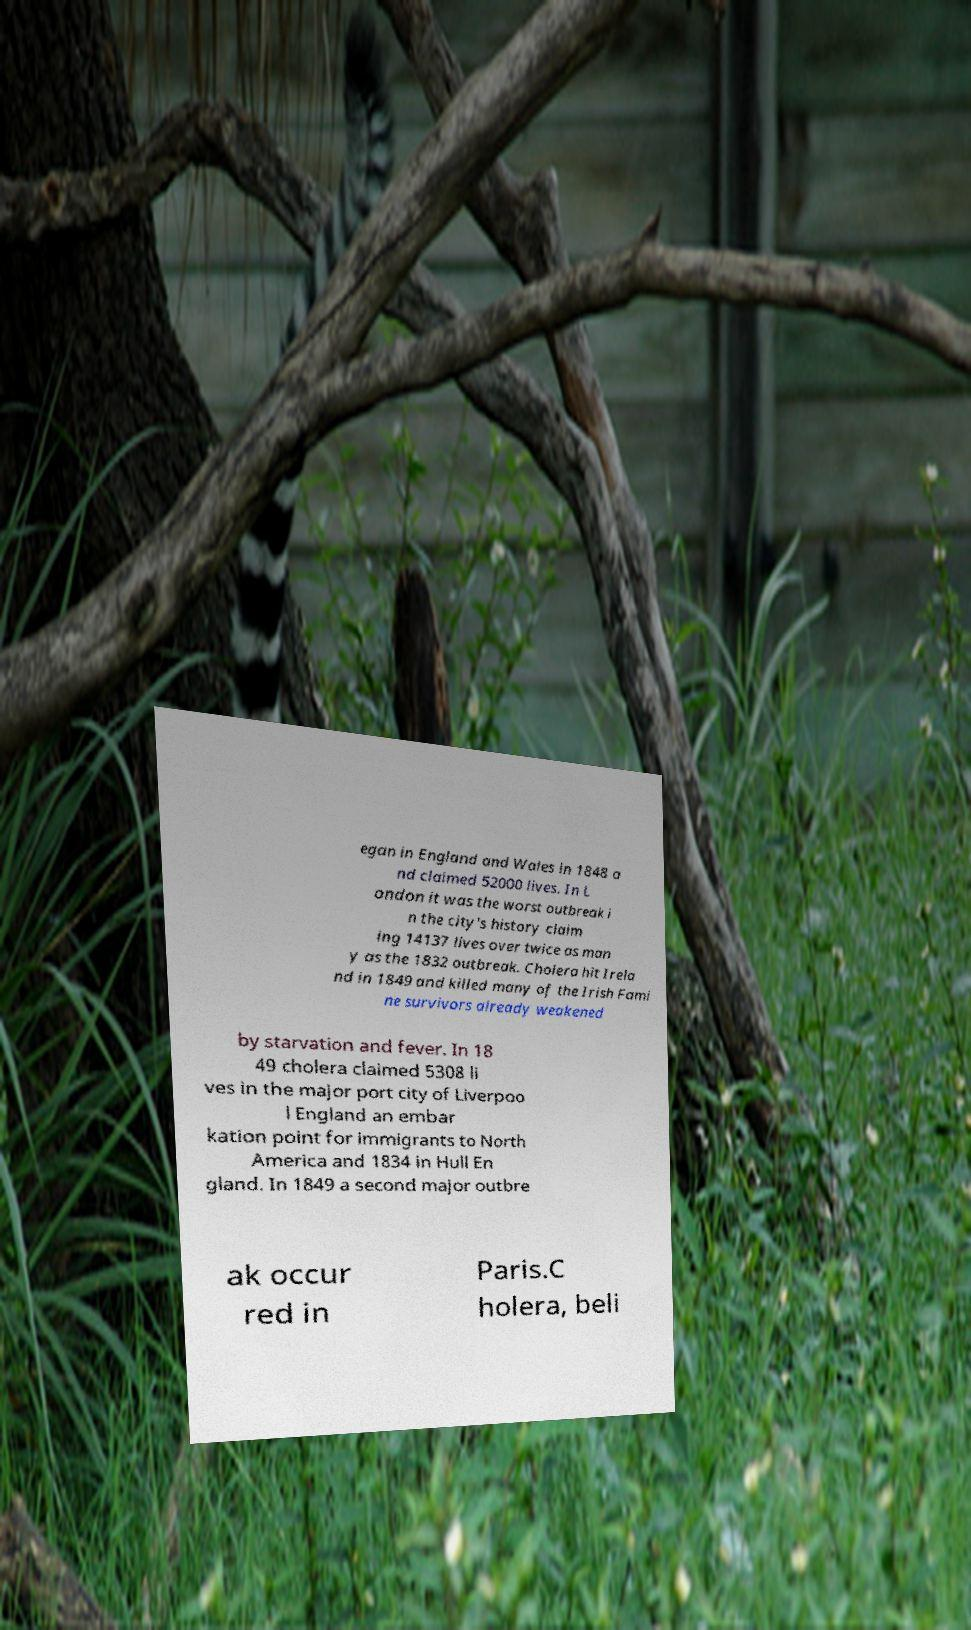What messages or text are displayed in this image? I need them in a readable, typed format. egan in England and Wales in 1848 a nd claimed 52000 lives. In L ondon it was the worst outbreak i n the city's history claim ing 14137 lives over twice as man y as the 1832 outbreak. Cholera hit Irela nd in 1849 and killed many of the Irish Fami ne survivors already weakened by starvation and fever. In 18 49 cholera claimed 5308 li ves in the major port city of Liverpoo l England an embar kation point for immigrants to North America and 1834 in Hull En gland. In 1849 a second major outbre ak occur red in Paris.C holera, beli 